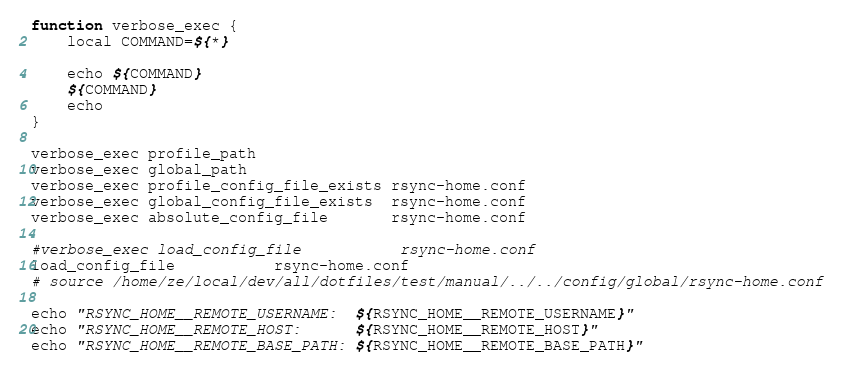<code> <loc_0><loc_0><loc_500><loc_500><_Bash_>function verbose_exec {
    local COMMAND=${*}

    echo ${COMMAND}
    ${COMMAND}
    echo
}

verbose_exec profile_path
verbose_exec global_path
verbose_exec profile_config_file_exists rsync-home.conf
verbose_exec global_config_file_exists  rsync-home.conf
verbose_exec absolute_config_file       rsync-home.conf

#verbose_exec load_config_file           rsync-home.conf
load_config_file           rsync-home.conf
# source /home/ze/local/dev/all/dotfiles/test/manual/../../config/global/rsync-home.conf

echo "RSYNC_HOME__REMOTE_USERNAME:  ${RSYNC_HOME__REMOTE_USERNAME}"
echo "RSYNC_HOME__REMOTE_HOST:      ${RSYNC_HOME__REMOTE_HOST}"
echo "RSYNC_HOME__REMOTE_BASE_PATH: ${RSYNC_HOME__REMOTE_BASE_PATH}"
</code> 